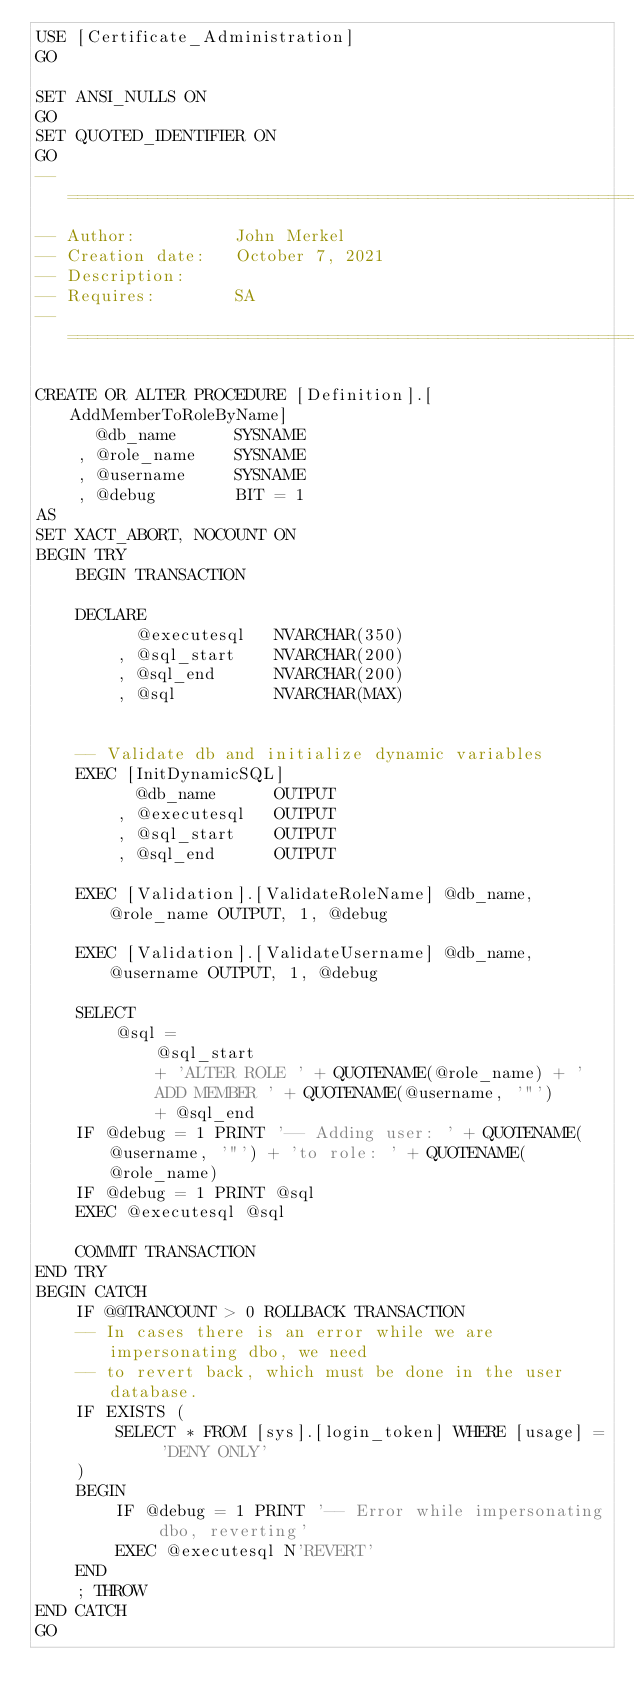<code> <loc_0><loc_0><loc_500><loc_500><_SQL_>USE [Certificate_Administration]
GO

SET ANSI_NULLS ON
GO
SET QUOTED_IDENTIFIER ON
GO
-- ======================================================================
-- Author:          John Merkel
-- Creation date:   October 7, 2021
-- Description:     
-- Requires:        SA
-- ======================================================================

CREATE OR ALTER PROCEDURE [Definition].[AddMemberToRoleByName]
      @db_name      SYSNAME
    , @role_name    SYSNAME
    , @username     SYSNAME
    , @debug        BIT = 1
AS
SET XACT_ABORT, NOCOUNT ON
BEGIN TRY
    BEGIN TRANSACTION

    DECLARE
          @executesql   NVARCHAR(350)
        , @sql_start    NVARCHAR(200)
        , @sql_end      NVARCHAR(200)
        , @sql          NVARCHAR(MAX)


    -- Validate db and initialize dynamic variables
    EXEC [InitDynamicSQL]
          @db_name      OUTPUT
        , @executesql   OUTPUT
        , @sql_start    OUTPUT
        , @sql_end      OUTPUT

    EXEC [Validation].[ValidateRoleName] @db_name, @role_name OUTPUT, 1, @debug

    EXEC [Validation].[ValidateUsername] @db_name, @username OUTPUT, 1, @debug

    SELECT
        @sql =
            @sql_start
            + 'ALTER ROLE ' + QUOTENAME(@role_name) + '
            ADD MEMBER ' + QUOTENAME(@username, '"')
            + @sql_end
    IF @debug = 1 PRINT '-- Adding user: ' + QUOTENAME(@username, '"') + 'to role: ' + QUOTENAME(@role_name)
    IF @debug = 1 PRINT @sql
    EXEC @executesql @sql

    COMMIT TRANSACTION
END TRY
BEGIN CATCH
    IF @@TRANCOUNT > 0 ROLLBACK TRANSACTION
    -- In cases there is an error while we are impersonating dbo, we need
    -- to revert back, which must be done in the user database.
    IF EXISTS (
        SELECT * FROM [sys].[login_token] WHERE [usage] = 'DENY ONLY'
    )
    BEGIN
        IF @debug = 1 PRINT '-- Error while impersonating dbo, reverting'
        EXEC @executesql N'REVERT'
    END
    ; THROW
END CATCH
GO
</code> 